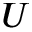Convert formula to latex. <formula><loc_0><loc_0><loc_500><loc_500>U</formula> 